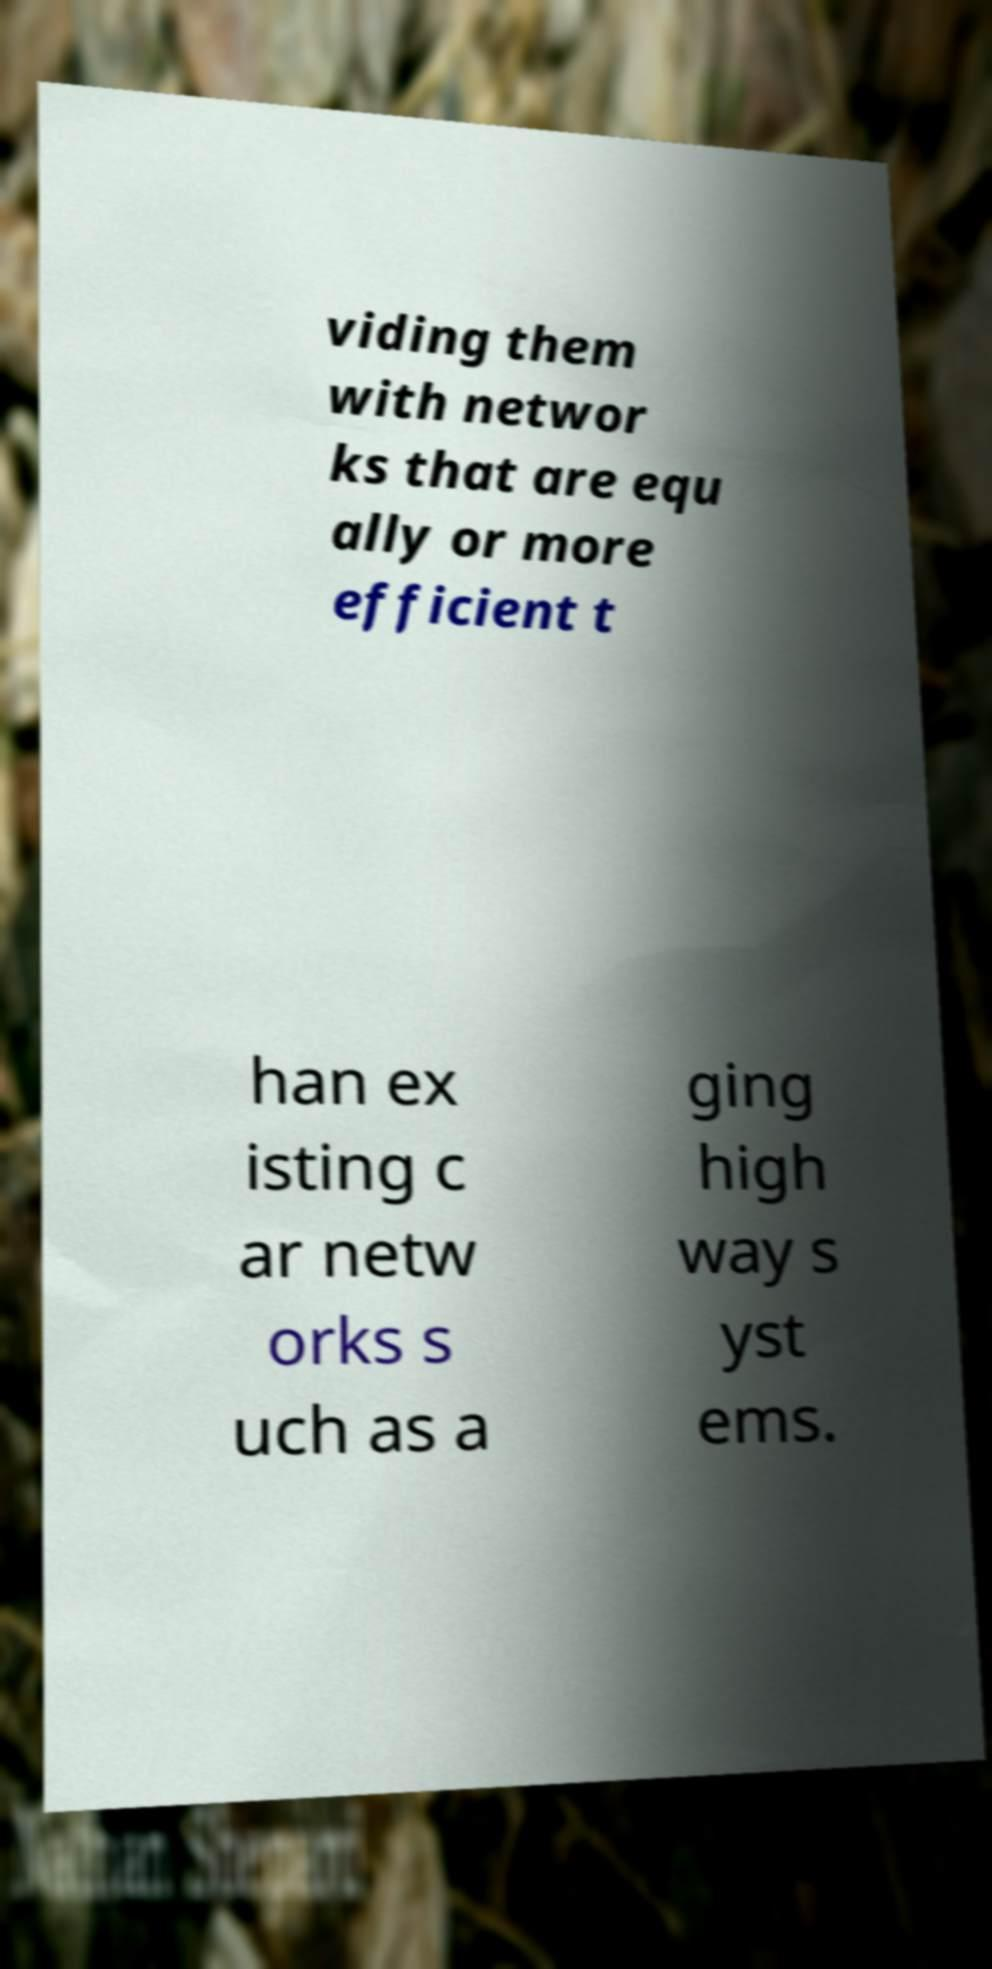Could you assist in decoding the text presented in this image and type it out clearly? viding them with networ ks that are equ ally or more efficient t han ex isting c ar netw orks s uch as a ging high way s yst ems. 